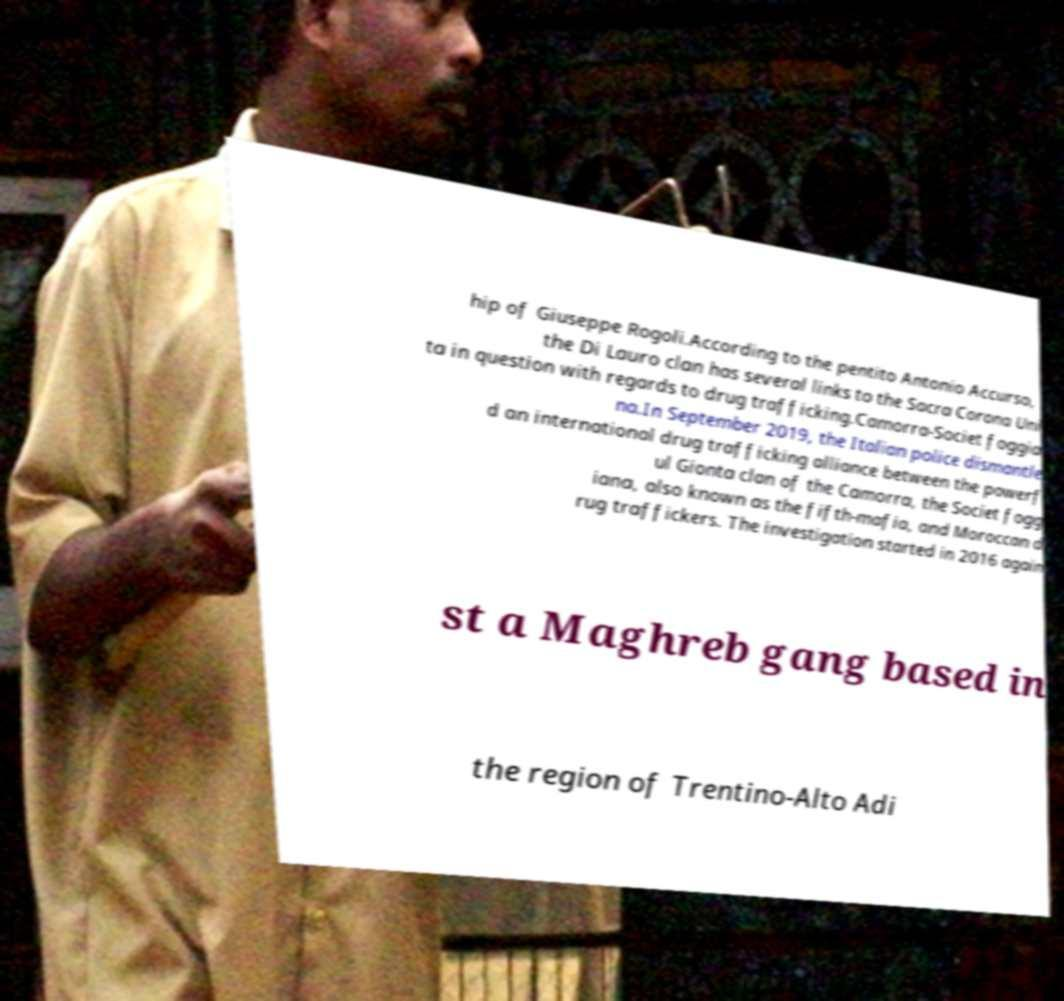Could you extract and type out the text from this image? hip of Giuseppe Rogoli.According to the pentito Antonio Accurso, the Di Lauro clan has several links to the Sacra Corona Uni ta in question with regards to drug trafficking.Camorra-Societ foggia na.In September 2019, the Italian police dismantle d an international drug trafficking alliance between the powerf ul Gionta clan of the Camorra, the Societ fogg iana, also known as the fifth-mafia, and Moroccan d rug traffickers. The investigation started in 2016 again st a Maghreb gang based in the region of Trentino-Alto Adi 